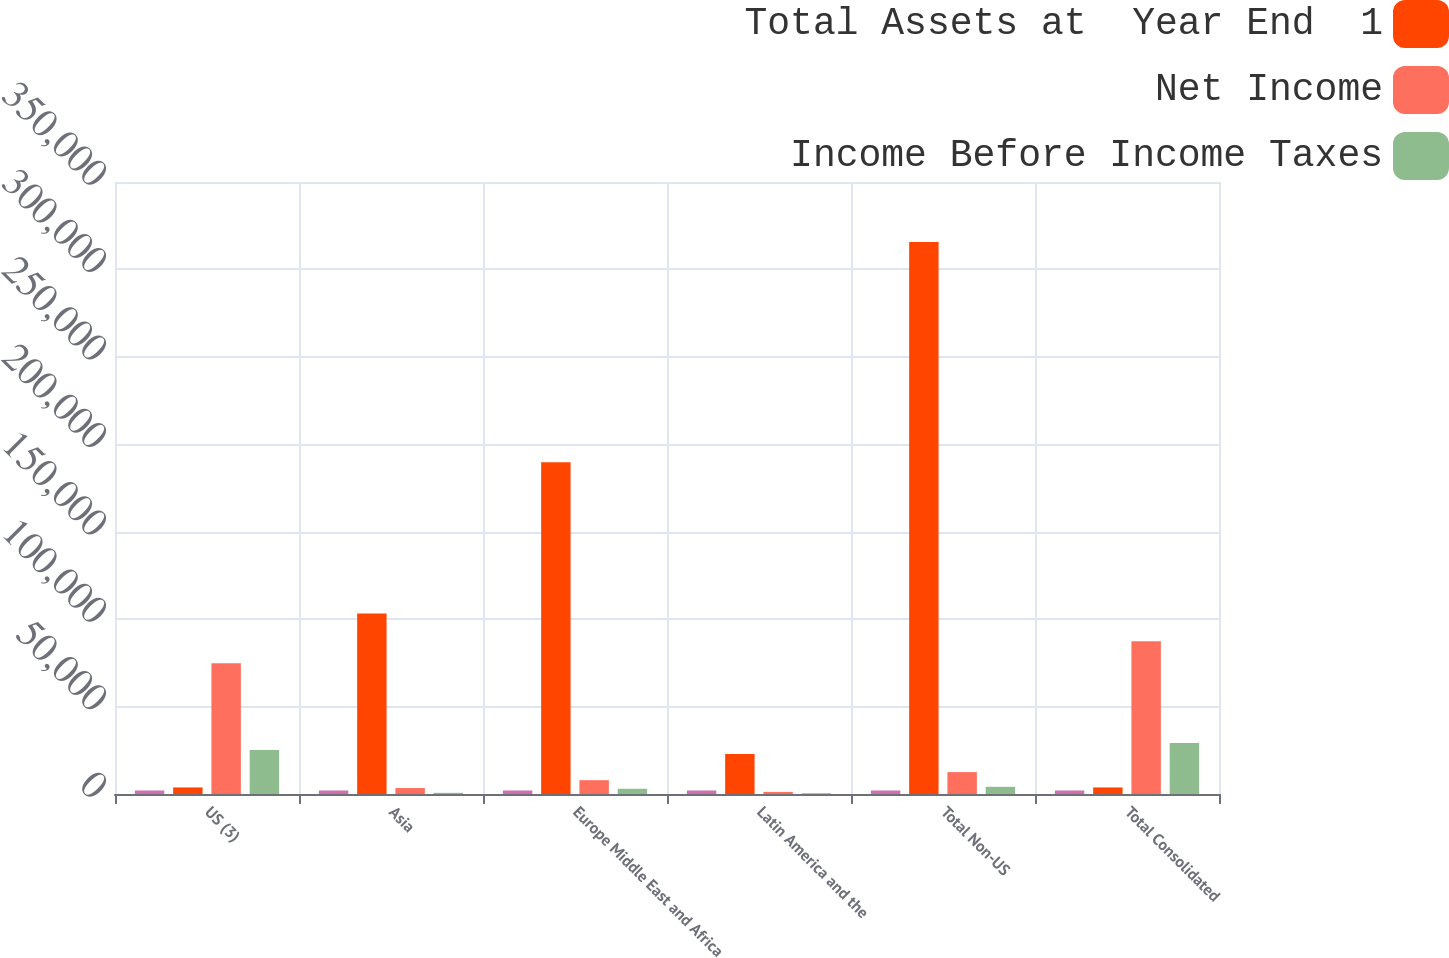Convert chart. <chart><loc_0><loc_0><loc_500><loc_500><stacked_bar_chart><ecel><fcel>US (3)<fcel>Asia<fcel>Europe Middle East and Africa<fcel>Latin America and the<fcel>Total Non-US<fcel>Total Consolidated<nl><fcel>nan<fcel>2017<fcel>2017<fcel>2017<fcel>2017<fcel>2017<fcel>2017<nl><fcel>Total Assets at  Year End  1<fcel>3755<fcel>103255<fcel>189661<fcel>22828<fcel>315744<fcel>3755<nl><fcel>Net Income<fcel>74830<fcel>3405<fcel>7907<fcel>1210<fcel>12522<fcel>87352<nl><fcel>Income Before Income Taxes<fcel>25108<fcel>676<fcel>2990<fcel>439<fcel>4105<fcel>29213<nl></chart> 